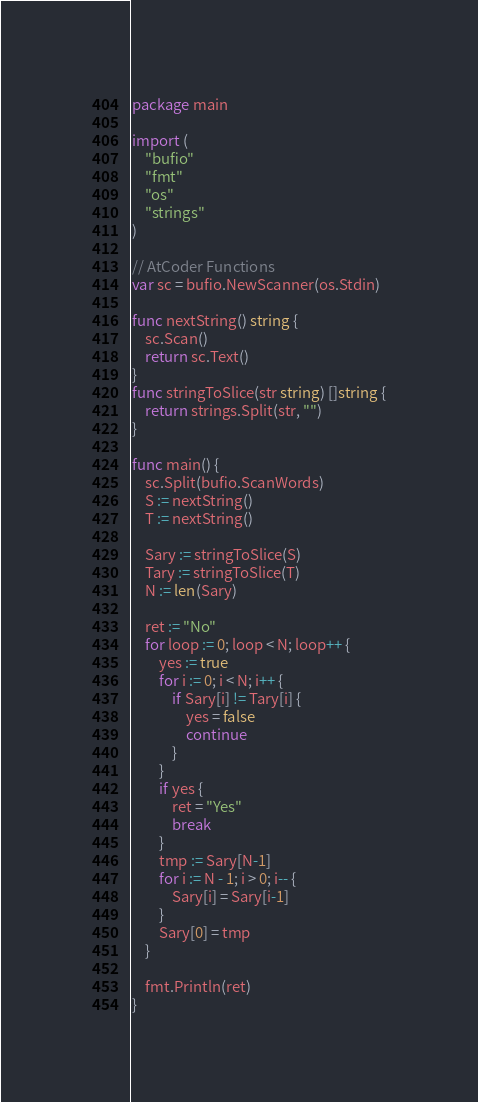<code> <loc_0><loc_0><loc_500><loc_500><_Go_>package main

import (
	"bufio"
	"fmt"
	"os"
	"strings"
)

// AtCoder Functions
var sc = bufio.NewScanner(os.Stdin)

func nextString() string {
	sc.Scan()
	return sc.Text()
}
func stringToSlice(str string) []string {
	return strings.Split(str, "")
}

func main() {
	sc.Split(bufio.ScanWords)
	S := nextString()
	T := nextString()

	Sary := stringToSlice(S)
	Tary := stringToSlice(T)
	N := len(Sary)

	ret := "No"
	for loop := 0; loop < N; loop++ {
		yes := true
		for i := 0; i < N; i++ {
			if Sary[i] != Tary[i] {
				yes = false
				continue
			}
		}
		if yes {
			ret = "Yes"
			break
		}
		tmp := Sary[N-1]
		for i := N - 1; i > 0; i-- {
			Sary[i] = Sary[i-1]
		}
		Sary[0] = tmp
	}

	fmt.Println(ret)
}
</code> 